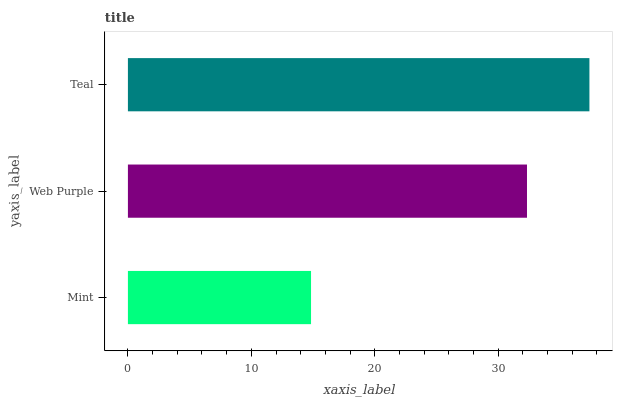Is Mint the minimum?
Answer yes or no. Yes. Is Teal the maximum?
Answer yes or no. Yes. Is Web Purple the minimum?
Answer yes or no. No. Is Web Purple the maximum?
Answer yes or no. No. Is Web Purple greater than Mint?
Answer yes or no. Yes. Is Mint less than Web Purple?
Answer yes or no. Yes. Is Mint greater than Web Purple?
Answer yes or no. No. Is Web Purple less than Mint?
Answer yes or no. No. Is Web Purple the high median?
Answer yes or no. Yes. Is Web Purple the low median?
Answer yes or no. Yes. Is Teal the high median?
Answer yes or no. No. Is Mint the low median?
Answer yes or no. No. 